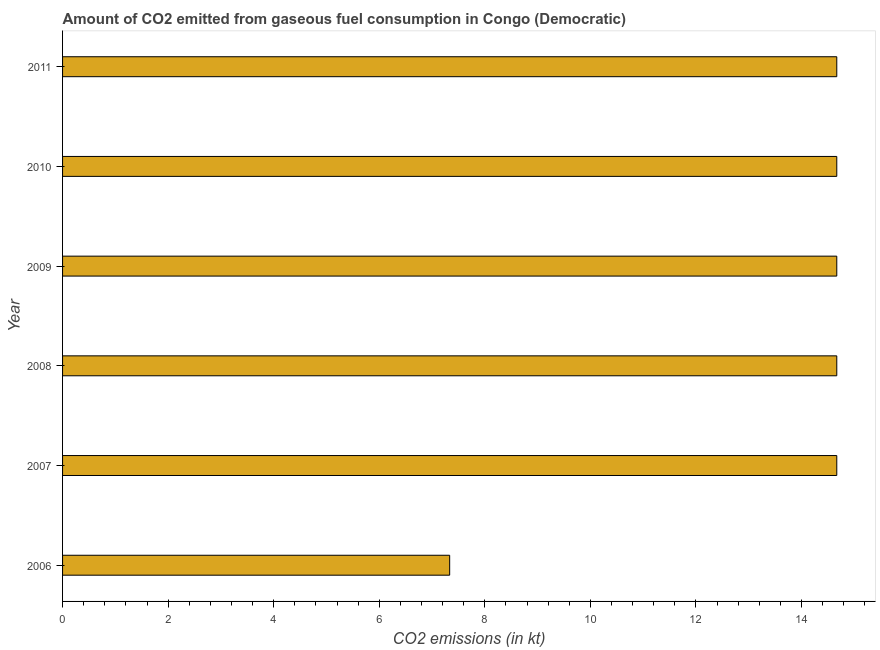Does the graph contain grids?
Your response must be concise. No. What is the title of the graph?
Make the answer very short. Amount of CO2 emitted from gaseous fuel consumption in Congo (Democratic). What is the label or title of the X-axis?
Ensure brevity in your answer.  CO2 emissions (in kt). What is the label or title of the Y-axis?
Keep it short and to the point. Year. What is the co2 emissions from gaseous fuel consumption in 2010?
Your answer should be compact. 14.67. Across all years, what is the maximum co2 emissions from gaseous fuel consumption?
Offer a terse response. 14.67. Across all years, what is the minimum co2 emissions from gaseous fuel consumption?
Provide a short and direct response. 7.33. In which year was the co2 emissions from gaseous fuel consumption minimum?
Offer a terse response. 2006. What is the sum of the co2 emissions from gaseous fuel consumption?
Provide a succinct answer. 80.67. What is the difference between the co2 emissions from gaseous fuel consumption in 2007 and 2009?
Give a very brief answer. 0. What is the average co2 emissions from gaseous fuel consumption per year?
Ensure brevity in your answer.  13.45. What is the median co2 emissions from gaseous fuel consumption?
Provide a succinct answer. 14.67. In how many years, is the co2 emissions from gaseous fuel consumption greater than 8.4 kt?
Offer a terse response. 5. Is the co2 emissions from gaseous fuel consumption in 2008 less than that in 2009?
Your response must be concise. No. Is the difference between the co2 emissions from gaseous fuel consumption in 2010 and 2011 greater than the difference between any two years?
Your answer should be very brief. No. What is the difference between the highest and the lowest co2 emissions from gaseous fuel consumption?
Give a very brief answer. 7.33. How many bars are there?
Offer a very short reply. 6. Are all the bars in the graph horizontal?
Provide a short and direct response. Yes. How many years are there in the graph?
Give a very brief answer. 6. What is the difference between two consecutive major ticks on the X-axis?
Your answer should be very brief. 2. What is the CO2 emissions (in kt) of 2006?
Your answer should be compact. 7.33. What is the CO2 emissions (in kt) of 2007?
Your response must be concise. 14.67. What is the CO2 emissions (in kt) in 2008?
Your answer should be very brief. 14.67. What is the CO2 emissions (in kt) in 2009?
Your answer should be compact. 14.67. What is the CO2 emissions (in kt) of 2010?
Keep it short and to the point. 14.67. What is the CO2 emissions (in kt) of 2011?
Offer a very short reply. 14.67. What is the difference between the CO2 emissions (in kt) in 2006 and 2007?
Offer a terse response. -7.33. What is the difference between the CO2 emissions (in kt) in 2006 and 2008?
Ensure brevity in your answer.  -7.33. What is the difference between the CO2 emissions (in kt) in 2006 and 2009?
Keep it short and to the point. -7.33. What is the difference between the CO2 emissions (in kt) in 2006 and 2010?
Offer a terse response. -7.33. What is the difference between the CO2 emissions (in kt) in 2006 and 2011?
Your answer should be compact. -7.33. What is the difference between the CO2 emissions (in kt) in 2007 and 2010?
Your response must be concise. 0. What is the difference between the CO2 emissions (in kt) in 2008 and 2010?
Ensure brevity in your answer.  0. What is the difference between the CO2 emissions (in kt) in 2008 and 2011?
Give a very brief answer. 0. What is the ratio of the CO2 emissions (in kt) in 2006 to that in 2007?
Your response must be concise. 0.5. What is the ratio of the CO2 emissions (in kt) in 2006 to that in 2010?
Your answer should be very brief. 0.5. What is the ratio of the CO2 emissions (in kt) in 2007 to that in 2008?
Your response must be concise. 1. What is the ratio of the CO2 emissions (in kt) in 2007 to that in 2009?
Ensure brevity in your answer.  1. What is the ratio of the CO2 emissions (in kt) in 2007 to that in 2011?
Keep it short and to the point. 1. What is the ratio of the CO2 emissions (in kt) in 2008 to that in 2009?
Your response must be concise. 1. What is the ratio of the CO2 emissions (in kt) in 2008 to that in 2011?
Provide a short and direct response. 1. What is the ratio of the CO2 emissions (in kt) in 2009 to that in 2010?
Provide a short and direct response. 1. 